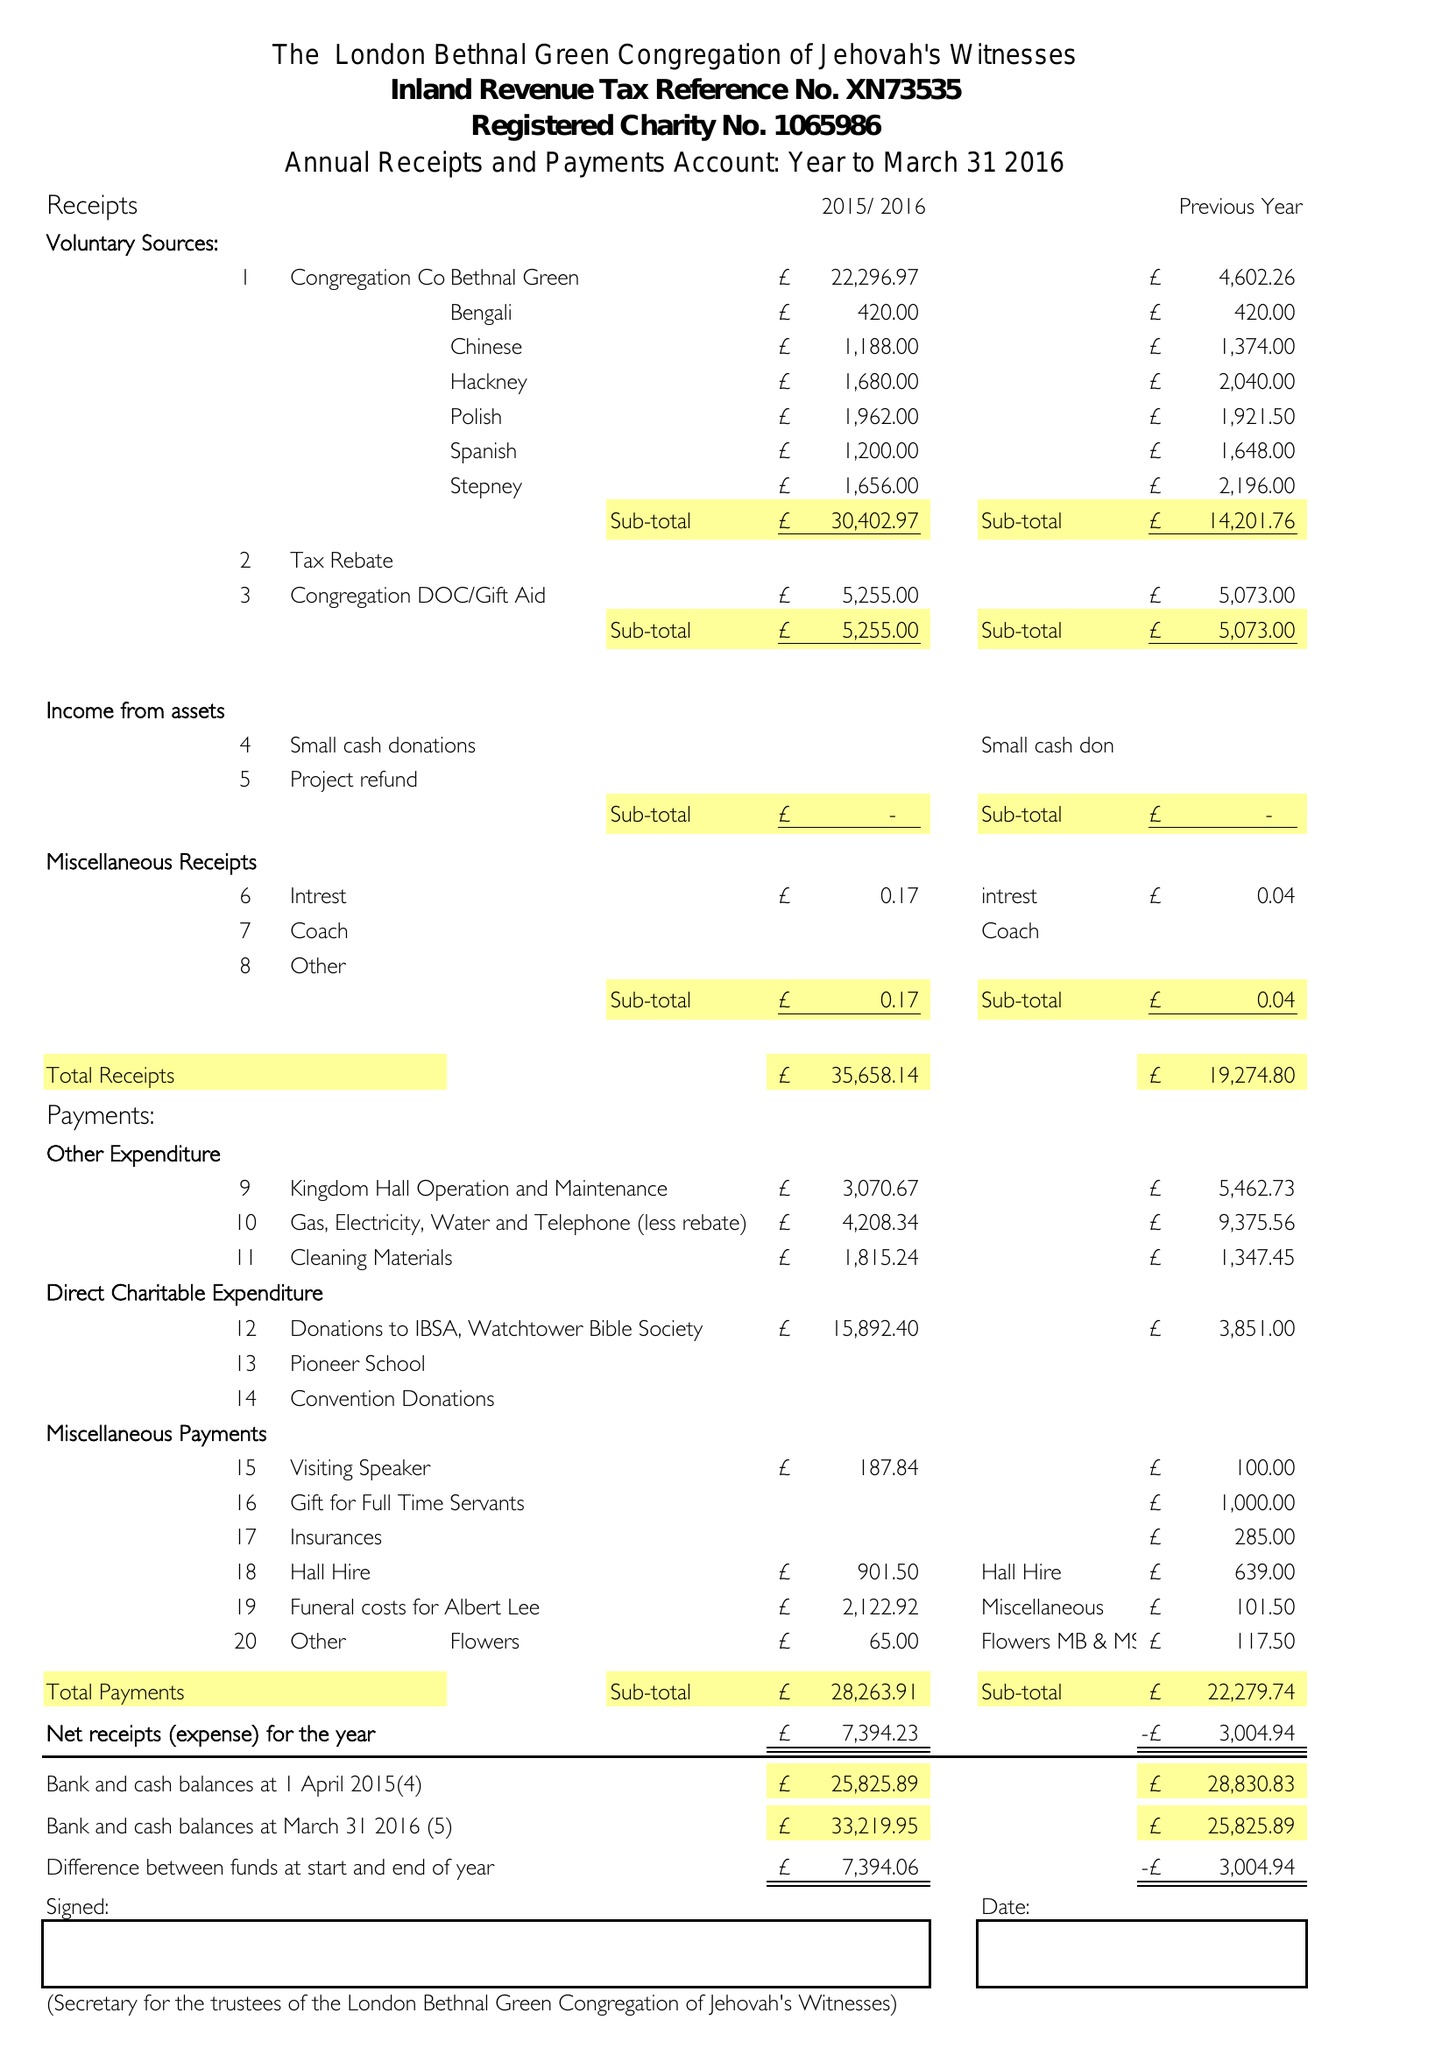What is the value for the report_date?
Answer the question using a single word or phrase. 2016-03-31 